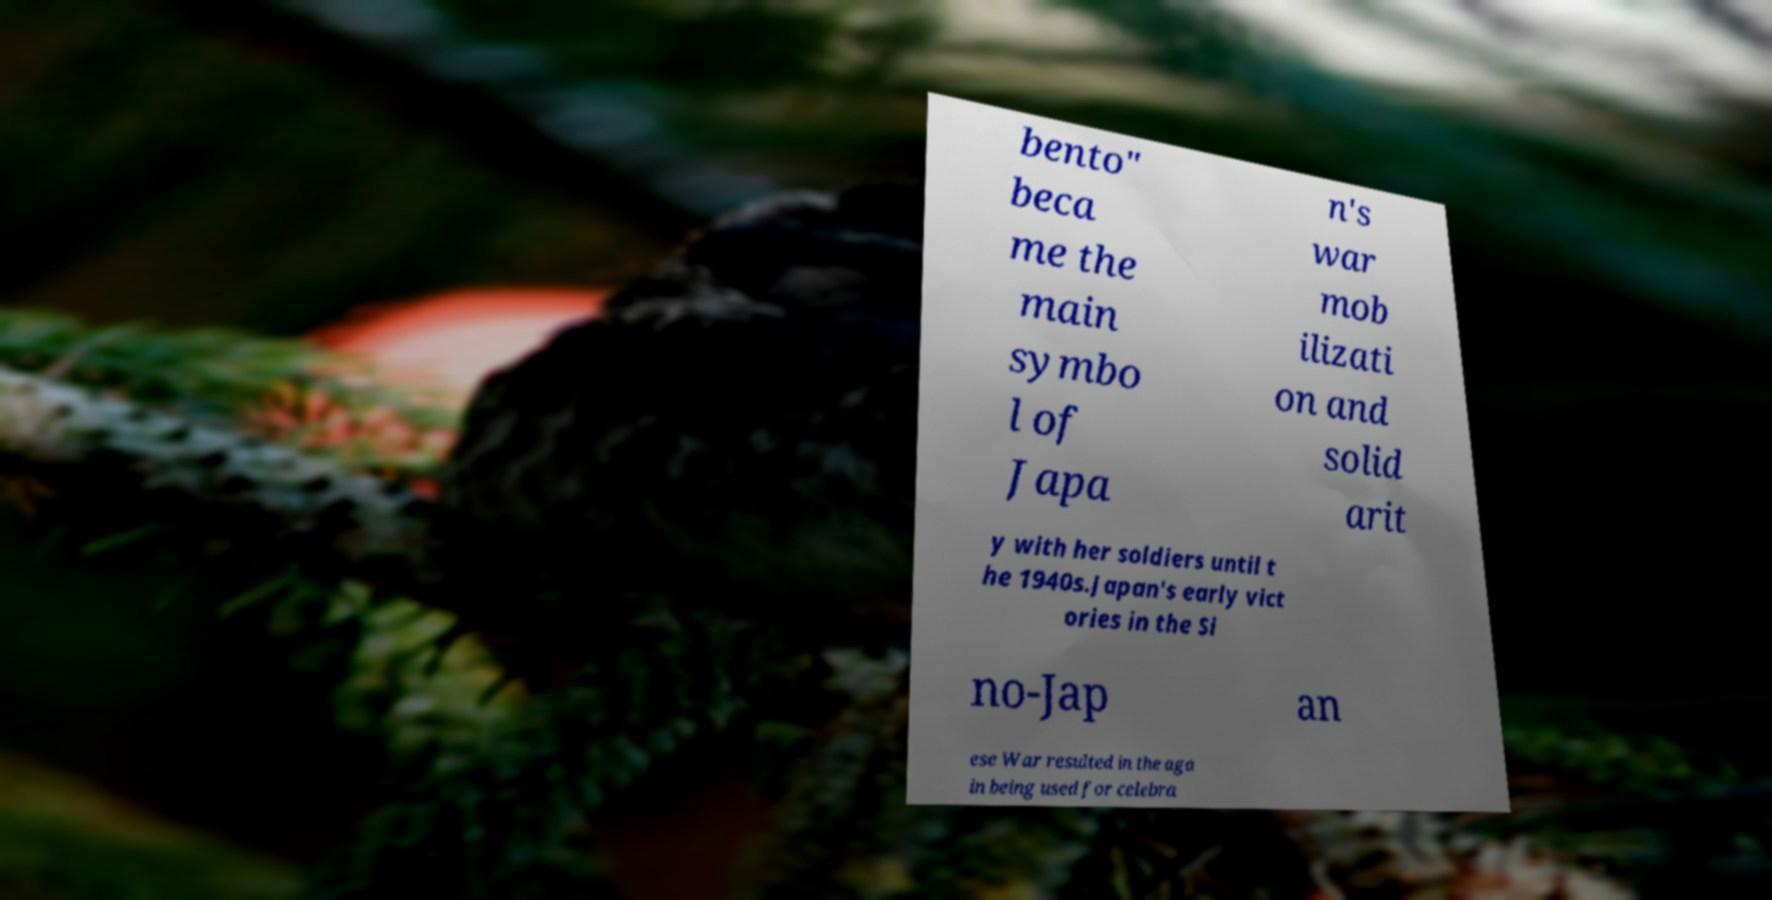Please read and relay the text visible in this image. What does it say? bento" beca me the main symbo l of Japa n's war mob ilizati on and solid arit y with her soldiers until t he 1940s.Japan's early vict ories in the Si no-Jap an ese War resulted in the aga in being used for celebra 